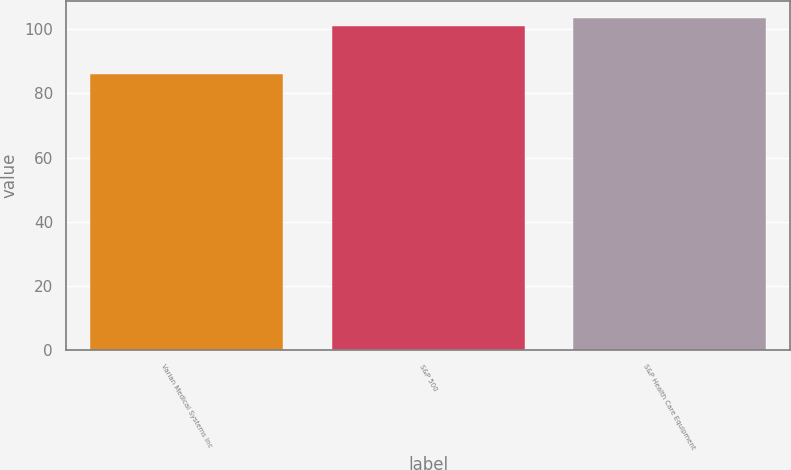<chart> <loc_0><loc_0><loc_500><loc_500><bar_chart><fcel>Varian Medical Systems Inc<fcel>S&P 500<fcel>S&P Health Care Equipment<nl><fcel>85.96<fcel>101.14<fcel>103.61<nl></chart> 